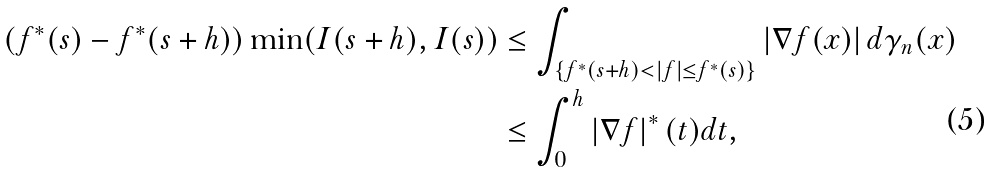<formula> <loc_0><loc_0><loc_500><loc_500>\left ( f ^ { \ast } ( s ) - f ^ { \ast } ( s + h ) \right ) \min ( I ( s + h ) , I ( s ) ) & \leq \int _ { \left \{ f ^ { \ast } ( s + h ) < \left | f \right | \leq f ^ { \ast } ( s ) \right \} } \left | \nabla f ( x ) \right | d \gamma _ { n } ( x ) \\ & \leq \int _ { 0 } ^ { h } \left | \nabla f \right | ^ { \ast } ( t ) d t ,</formula> 